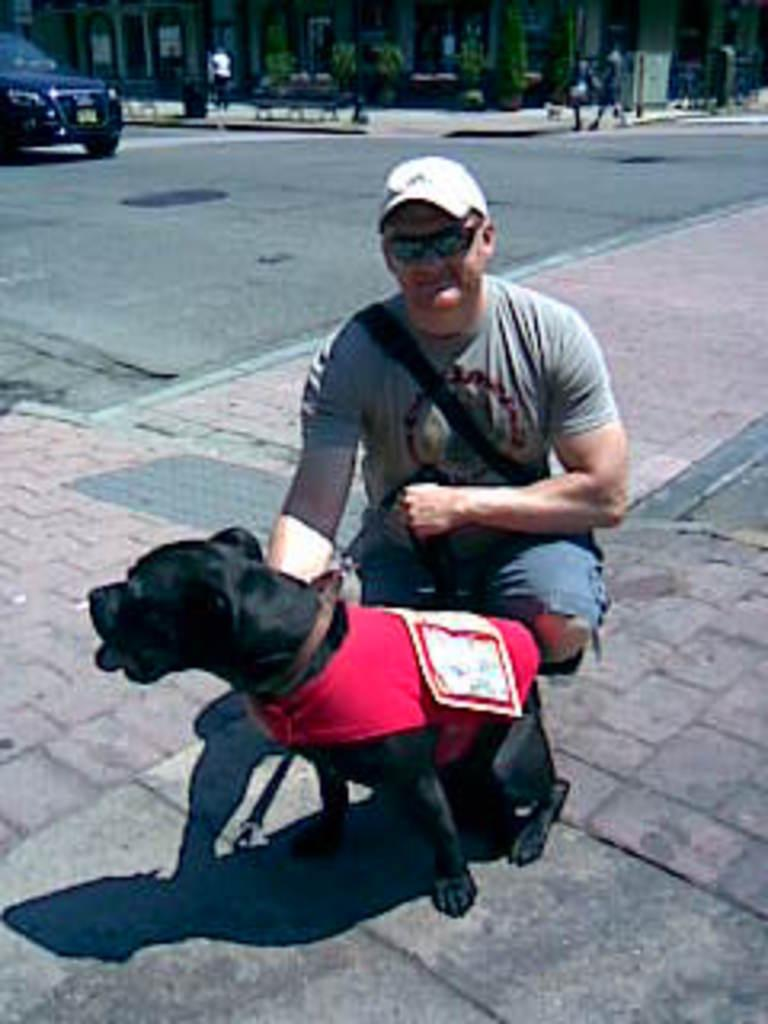Who is present in the image? There is a person in the image. What is the person wearing on their head? The person is wearing a cap. What is the person holding in the image? The person is holding a dog. What can be seen on the road in the image? There is a car on the road in the image. What is visible in the background of the image? There are people and a building in the background of the image. What type of substance is falling from the sky in the image? There is no substance falling from the sky in the image; it does not depict a rainstorm. What type of food is the person eating in the image? The image does not show the person eating any food. 